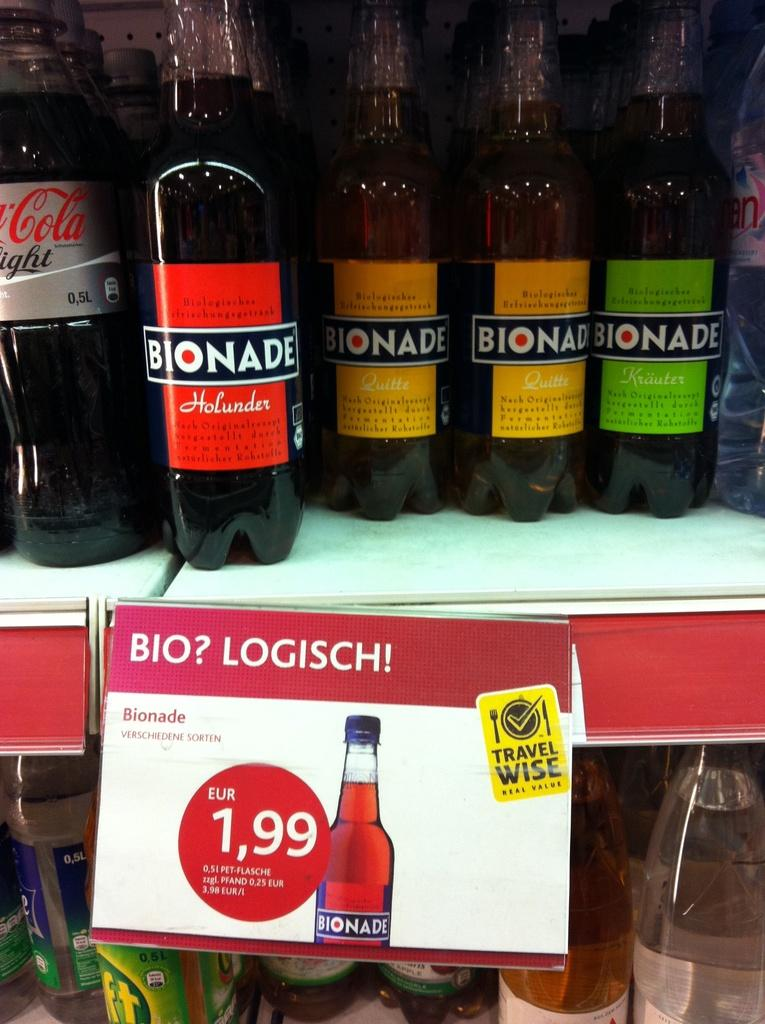<image>
Give a short and clear explanation of the subsequent image. the word bionade is on some of the bottles 